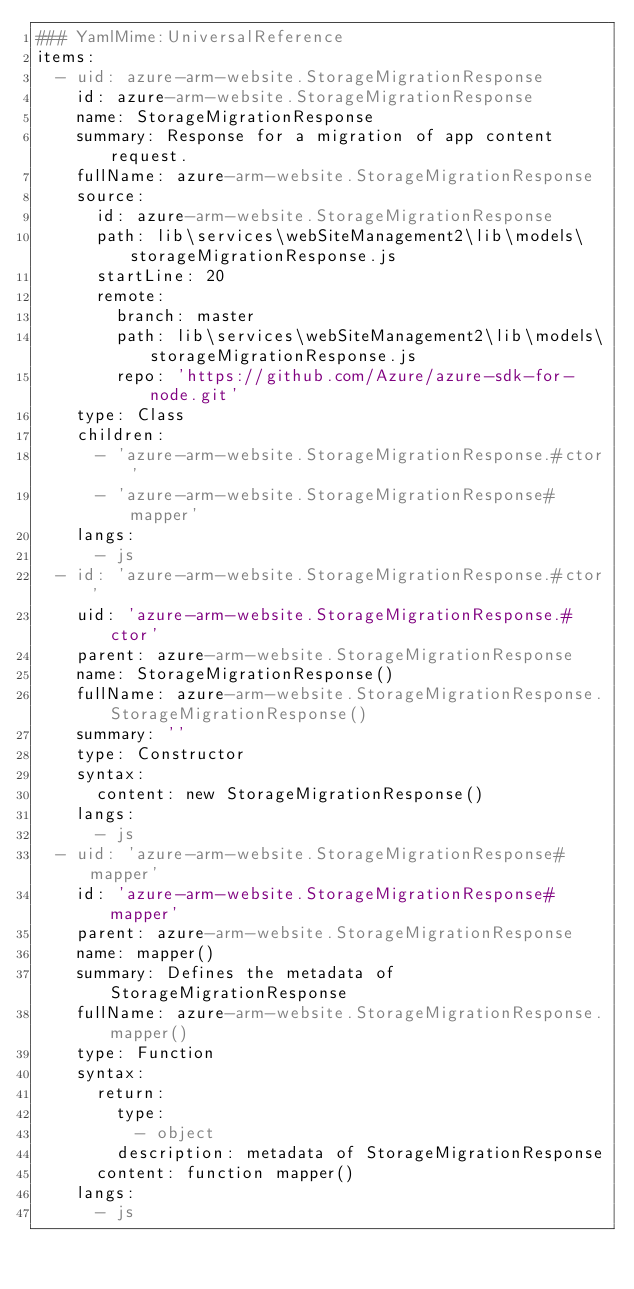<code> <loc_0><loc_0><loc_500><loc_500><_YAML_>### YamlMime:UniversalReference
items:
  - uid: azure-arm-website.StorageMigrationResponse
    id: azure-arm-website.StorageMigrationResponse
    name: StorageMigrationResponse
    summary: Response for a migration of app content request.
    fullName: azure-arm-website.StorageMigrationResponse
    source:
      id: azure-arm-website.StorageMigrationResponse
      path: lib\services\webSiteManagement2\lib\models\storageMigrationResponse.js
      startLine: 20
      remote:
        branch: master
        path: lib\services\webSiteManagement2\lib\models\storageMigrationResponse.js
        repo: 'https://github.com/Azure/azure-sdk-for-node.git'
    type: Class
    children:
      - 'azure-arm-website.StorageMigrationResponse.#ctor'
      - 'azure-arm-website.StorageMigrationResponse#mapper'
    langs:
      - js
  - id: 'azure-arm-website.StorageMigrationResponse.#ctor'
    uid: 'azure-arm-website.StorageMigrationResponse.#ctor'
    parent: azure-arm-website.StorageMigrationResponse
    name: StorageMigrationResponse()
    fullName: azure-arm-website.StorageMigrationResponse.StorageMigrationResponse()
    summary: ''
    type: Constructor
    syntax:
      content: new StorageMigrationResponse()
    langs:
      - js
  - uid: 'azure-arm-website.StorageMigrationResponse#mapper'
    id: 'azure-arm-website.StorageMigrationResponse#mapper'
    parent: azure-arm-website.StorageMigrationResponse
    name: mapper()
    summary: Defines the metadata of StorageMigrationResponse
    fullName: azure-arm-website.StorageMigrationResponse.mapper()
    type: Function
    syntax:
      return:
        type:
          - object
        description: metadata of StorageMigrationResponse
      content: function mapper()
    langs:
      - js
</code> 